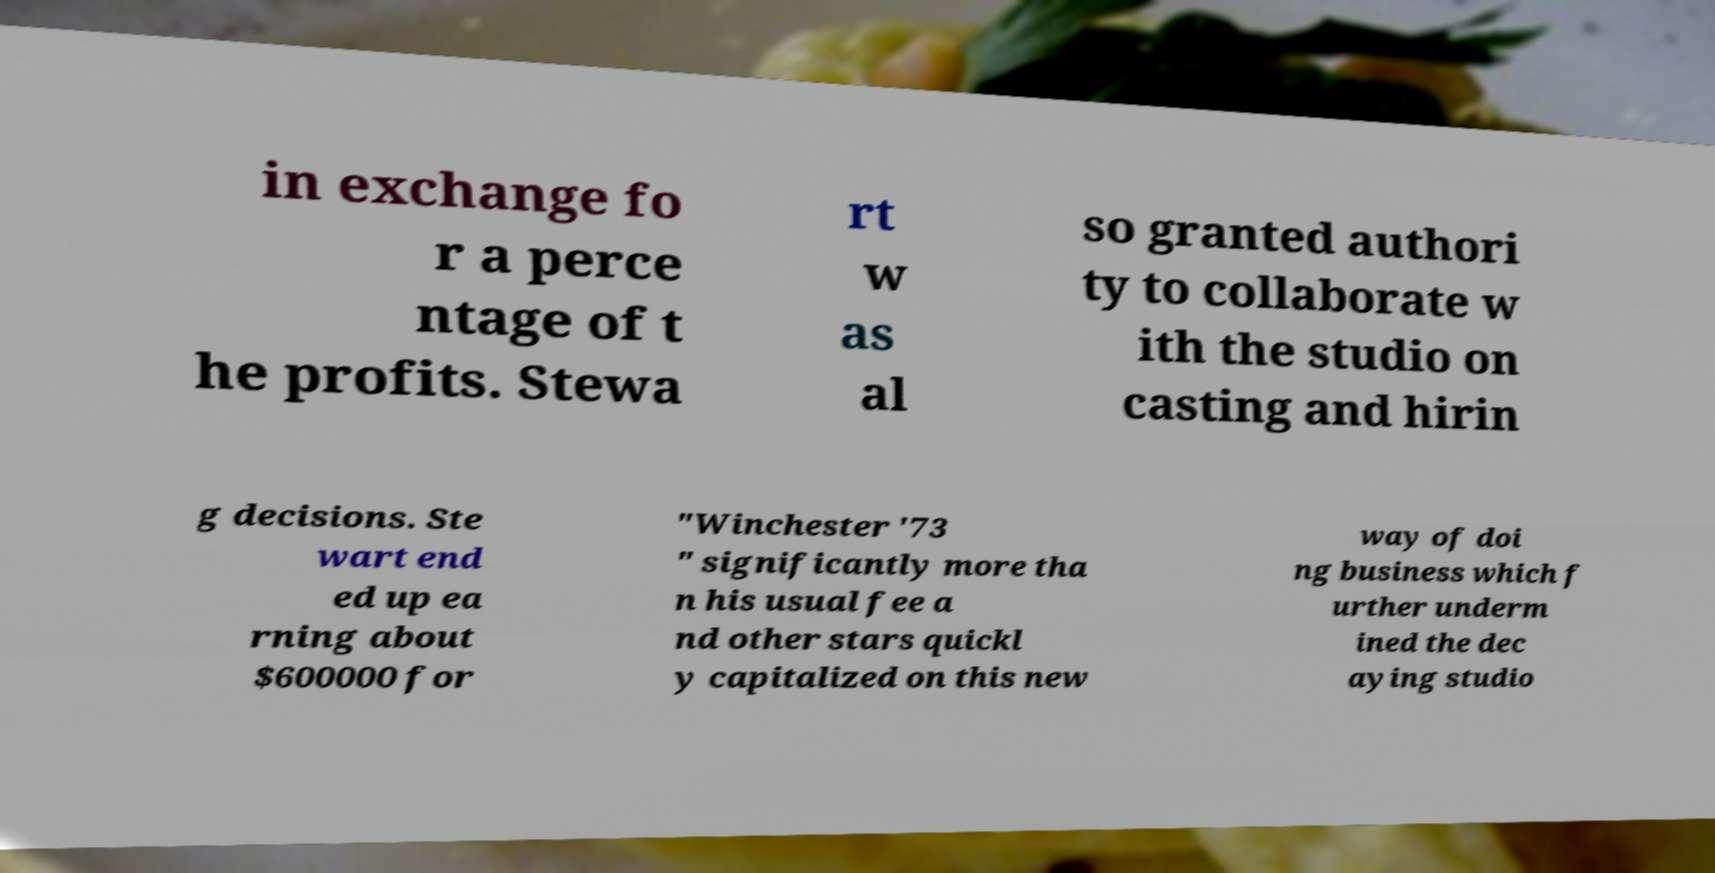Can you accurately transcribe the text from the provided image for me? in exchange fo r a perce ntage of t he profits. Stewa rt w as al so granted authori ty to collaborate w ith the studio on casting and hirin g decisions. Ste wart end ed up ea rning about $600000 for "Winchester '73 " significantly more tha n his usual fee a nd other stars quickl y capitalized on this new way of doi ng business which f urther underm ined the dec aying studio 